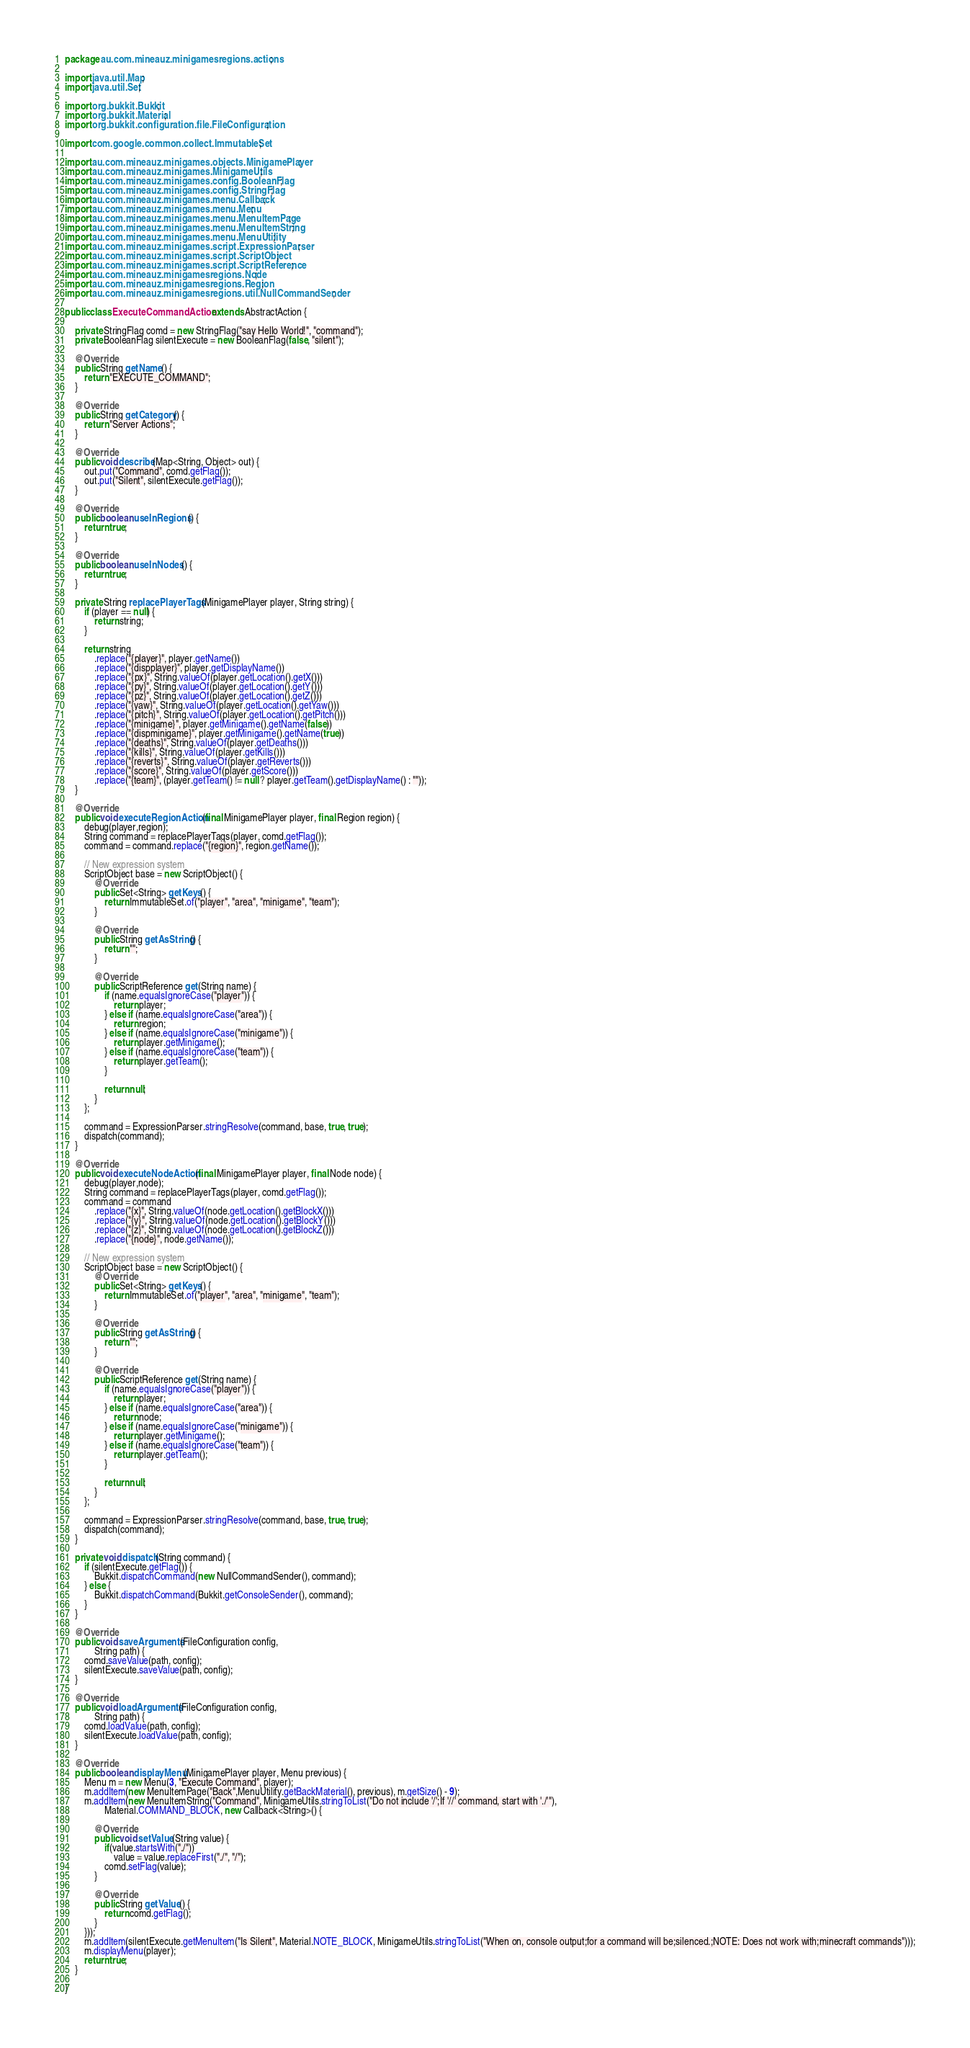Convert code to text. <code><loc_0><loc_0><loc_500><loc_500><_Java_>package au.com.mineauz.minigamesregions.actions;

import java.util.Map;
import java.util.Set;

import org.bukkit.Bukkit;
import org.bukkit.Material;
import org.bukkit.configuration.file.FileConfiguration;

import com.google.common.collect.ImmutableSet;

import au.com.mineauz.minigames.objects.MinigamePlayer;
import au.com.mineauz.minigames.MinigameUtils;
import au.com.mineauz.minigames.config.BooleanFlag;
import au.com.mineauz.minigames.config.StringFlag;
import au.com.mineauz.minigames.menu.Callback;
import au.com.mineauz.minigames.menu.Menu;
import au.com.mineauz.minigames.menu.MenuItemPage;
import au.com.mineauz.minigames.menu.MenuItemString;
import au.com.mineauz.minigames.menu.MenuUtility;
import au.com.mineauz.minigames.script.ExpressionParser;
import au.com.mineauz.minigames.script.ScriptObject;
import au.com.mineauz.minigames.script.ScriptReference;
import au.com.mineauz.minigamesregions.Node;
import au.com.mineauz.minigamesregions.Region;
import au.com.mineauz.minigamesregions.util.NullCommandSender;

public class ExecuteCommandAction extends AbstractAction {
    
    private StringFlag comd = new StringFlag("say Hello World!", "command");
    private BooleanFlag silentExecute = new BooleanFlag(false, "silent");

    @Override
    public String getName() {
        return "EXECUTE_COMMAND";
    }

    @Override
    public String getCategory() {
        return "Server Actions";
    }
    
    @Override
    public void describe(Map<String, Object> out) {
        out.put("Command", comd.getFlag());
        out.put("Silent", silentExecute.getFlag());
    }

    @Override
    public boolean useInRegions() {
        return true;
    }

    @Override
    public boolean useInNodes() {
        return true;
    }
    
    private String replacePlayerTags(MinigamePlayer player, String string) {
        if (player == null) {
            return string;
        }
        
        return string
            .replace("{player}", player.getName())
            .replace("{dispplayer}", player.getDisplayName())
            .replace("{px}", String.valueOf(player.getLocation().getX()))
            .replace("{py}", String.valueOf(player.getLocation().getY()))
            .replace("{pz}", String.valueOf(player.getLocation().getZ()))
            .replace("{yaw}", String.valueOf(player.getLocation().getYaw()))
            .replace("{pitch}", String.valueOf(player.getLocation().getPitch()))
            .replace("{minigame}", player.getMinigame().getName(false))
            .replace("{dispminigame}", player.getMinigame().getName(true))
            .replace("{deaths}", String.valueOf(player.getDeaths()))
            .replace("{kills}", String.valueOf(player.getKills()))
            .replace("{reverts}", String.valueOf(player.getReverts()))
            .replace("{score}", String.valueOf(player.getScore()))
            .replace("{team}", (player.getTeam() != null ? player.getTeam().getDisplayName() : ""));
    }

    @Override
    public void executeRegionAction(final MinigamePlayer player, final Region region) {
        debug(player,region);
        String command = replacePlayerTags(player, comd.getFlag());
        command = command.replace("{region}", region.getName());
        
        // New expression system
        ScriptObject base = new ScriptObject() {
            @Override
            public Set<String> getKeys() {
                return ImmutableSet.of("player", "area", "minigame", "team");
            }
            
            @Override
            public String getAsString() {
                return "";
            }
            
            @Override
            public ScriptReference get(String name) {
                if (name.equalsIgnoreCase("player")) {
                    return player;
                } else if (name.equalsIgnoreCase("area")) {
                    return region;
                } else if (name.equalsIgnoreCase("minigame")) {
                    return player.getMinigame();
                } else if (name.equalsIgnoreCase("team")) {
                    return player.getTeam();
                }
                
                return null;
            }
        };
        
        command = ExpressionParser.stringResolve(command, base, true, true);
        dispatch(command);
    }

    @Override
    public void executeNodeAction(final MinigamePlayer player, final Node node) {
        debug(player,node);
        String command = replacePlayerTags(player, comd.getFlag());
        command = command
            .replace("{x}", String.valueOf(node.getLocation().getBlockX()))
            .replace("{y}", String.valueOf(node.getLocation().getBlockY()))
            .replace("{z}", String.valueOf(node.getLocation().getBlockZ()))
            .replace("{node}", node.getName());
        
        // New expression system
        ScriptObject base = new ScriptObject() {
            @Override
            public Set<String> getKeys() {
                return ImmutableSet.of("player", "area", "minigame", "team");
            }
            
            @Override
            public String getAsString() {
                return "";
            }
            
            @Override
            public ScriptReference get(String name) {
                if (name.equalsIgnoreCase("player")) {
                    return player;
                } else if (name.equalsIgnoreCase("area")) {
                    return node;
                } else if (name.equalsIgnoreCase("minigame")) {
                    return player.getMinigame();
                } else if (name.equalsIgnoreCase("team")) {
                    return player.getTeam();
                }
                
                return null;
            }
        };
        
        command = ExpressionParser.stringResolve(command, base, true, true);
        dispatch(command);
    }
    
    private void dispatch(String command) {
        if (silentExecute.getFlag()) {
            Bukkit.dispatchCommand(new NullCommandSender(), command);
        } else {
            Bukkit.dispatchCommand(Bukkit.getConsoleSender(), command);
        }
    }
    
    @Override
    public void saveArguments(FileConfiguration config,
            String path) {
        comd.saveValue(path, config);
        silentExecute.saveValue(path, config);
    }

    @Override
    public void loadArguments(FileConfiguration config,
            String path) {
        comd.loadValue(path, config);
        silentExecute.loadValue(path, config);
    }

    @Override
    public boolean displayMenu(MinigamePlayer player, Menu previous) {
        Menu m = new Menu(3, "Execute Command", player);
        m.addItem(new MenuItemPage("Back",MenuUtility.getBackMaterial(), previous), m.getSize() - 9);
        m.addItem(new MenuItemString("Command", MinigameUtils.stringToList("Do not include '/';If '//' command, start with './'"),
                Material.COMMAND_BLOCK, new Callback<String>() {
            
            @Override
            public void setValue(String value) {
                if(value.startsWith("./"))
                    value = value.replaceFirst("./", "/");
                comd.setFlag(value);
            }
            
            @Override
            public String getValue() {
                return comd.getFlag();
            }
        }));
        m.addItem(silentExecute.getMenuItem("Is Silent", Material.NOTE_BLOCK, MinigameUtils.stringToList("When on, console output;for a command will be;silenced.;NOTE: Does not work with;minecraft commands")));
        m.displayMenu(player);
        return true;
    }

}
</code> 